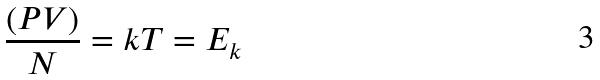Convert formula to latex. <formula><loc_0><loc_0><loc_500><loc_500>\frac { ( P V ) } { N } = k T = E _ { k }</formula> 